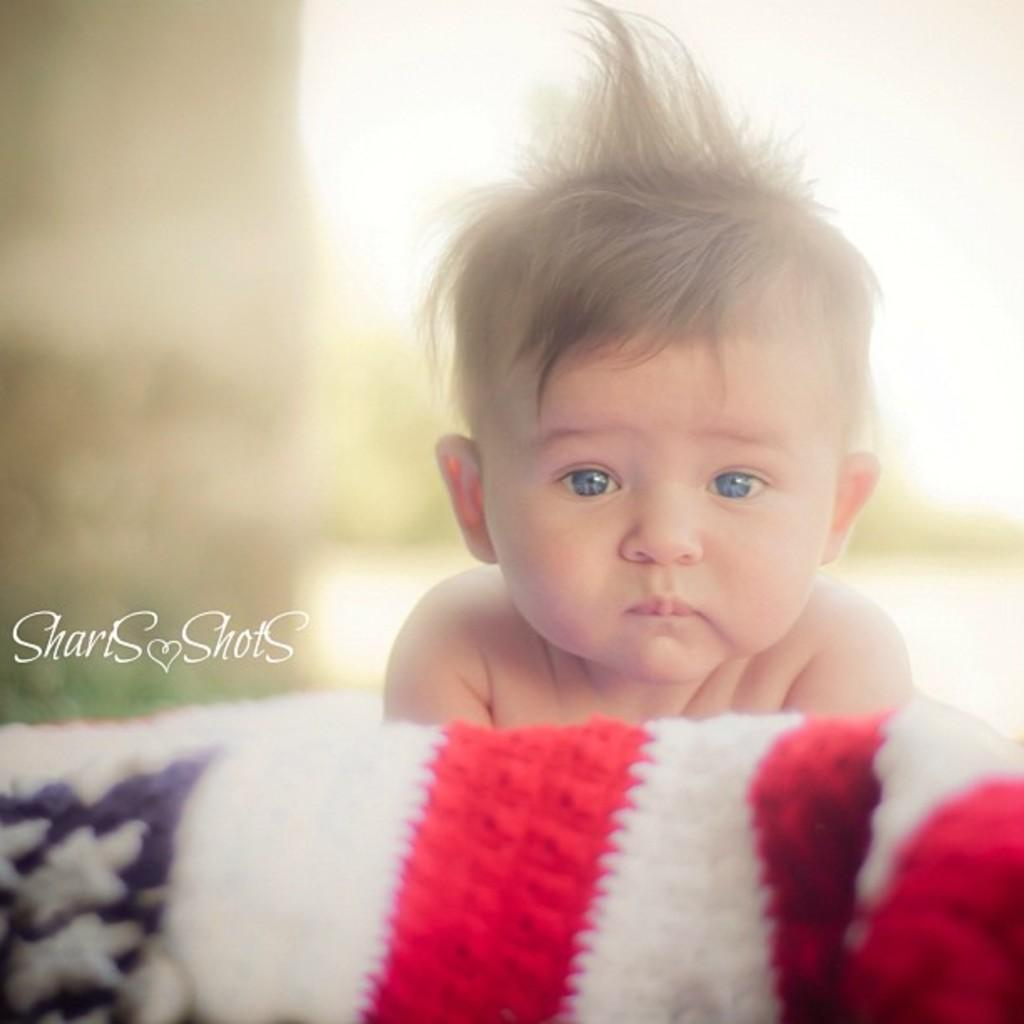What is the main subject of the image? There is a baby in the image. What type of material is visible in the image? There is cloth visible in the image. How would you describe the background of the image? The background of the image is blurred. Can you describe any additional features of the image? There is a watermark on the image. What type of unit is the baby holding in the image? There is no unit visible in the image. What type of drug is the baby taking in the image? There is no drug present in the image. How many dimes can be seen in the image? There are no dimes present in the image. 